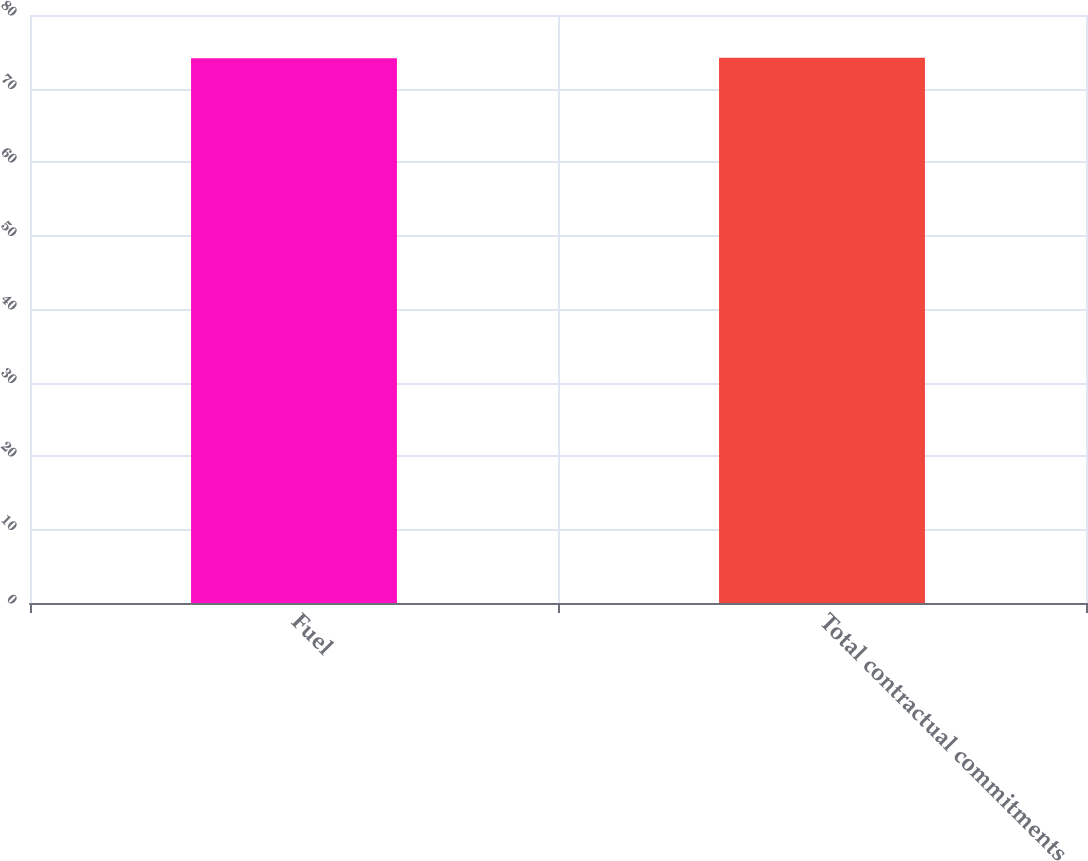<chart> <loc_0><loc_0><loc_500><loc_500><bar_chart><fcel>Fuel<fcel>Total contractual commitments<nl><fcel>74.1<fcel>74.2<nl></chart> 